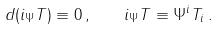Convert formula to latex. <formula><loc_0><loc_0><loc_500><loc_500>d ( i _ { \Psi } T ) \equiv 0 \, , \quad i _ { \Psi } T \equiv \Psi ^ { i } T _ { i } \, .</formula> 